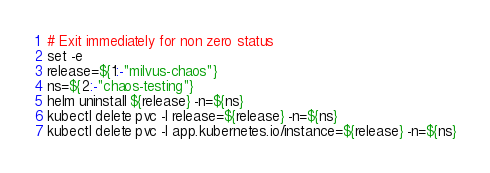Convert code to text. <code><loc_0><loc_0><loc_500><loc_500><_Bash_>
# Exit immediately for non zero status
set -e
release=${1:-"milvus-chaos"}
ns=${2:-"chaos-testing"}
helm uninstall ${release} -n=${ns}
kubectl delete pvc -l release=${release} -n=${ns}
kubectl delete pvc -l app.kubernetes.io/instance=${release} -n=${ns}
</code> 